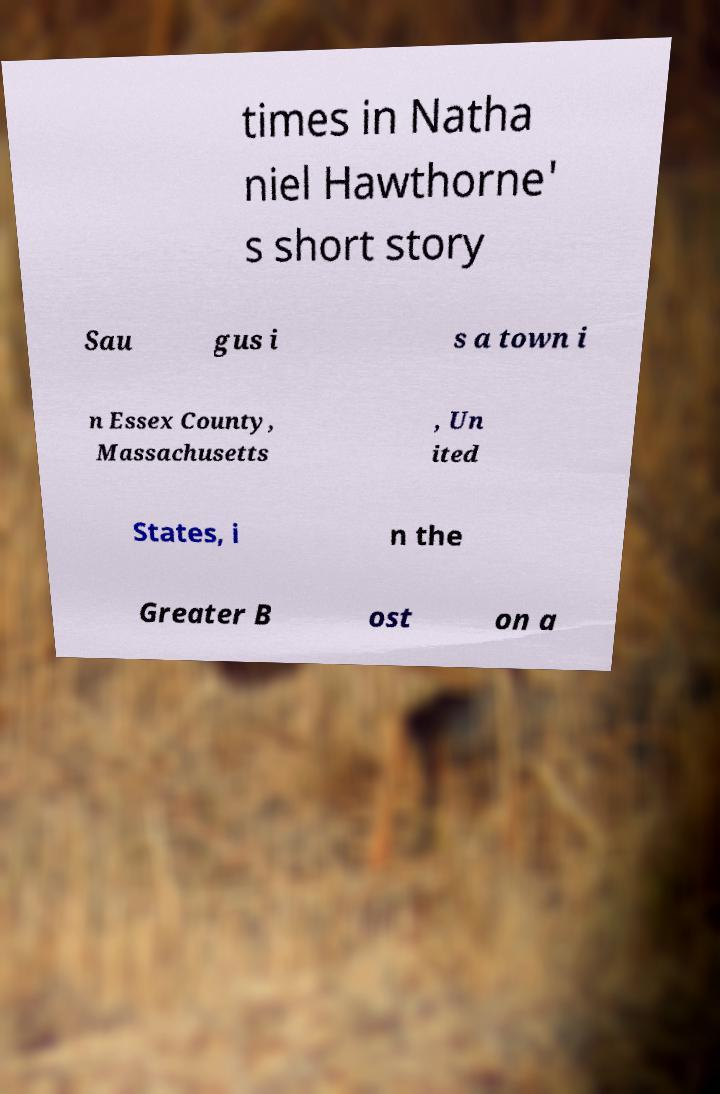I need the written content from this picture converted into text. Can you do that? times in Natha niel Hawthorne' s short story Sau gus i s a town i n Essex County, Massachusetts , Un ited States, i n the Greater B ost on a 